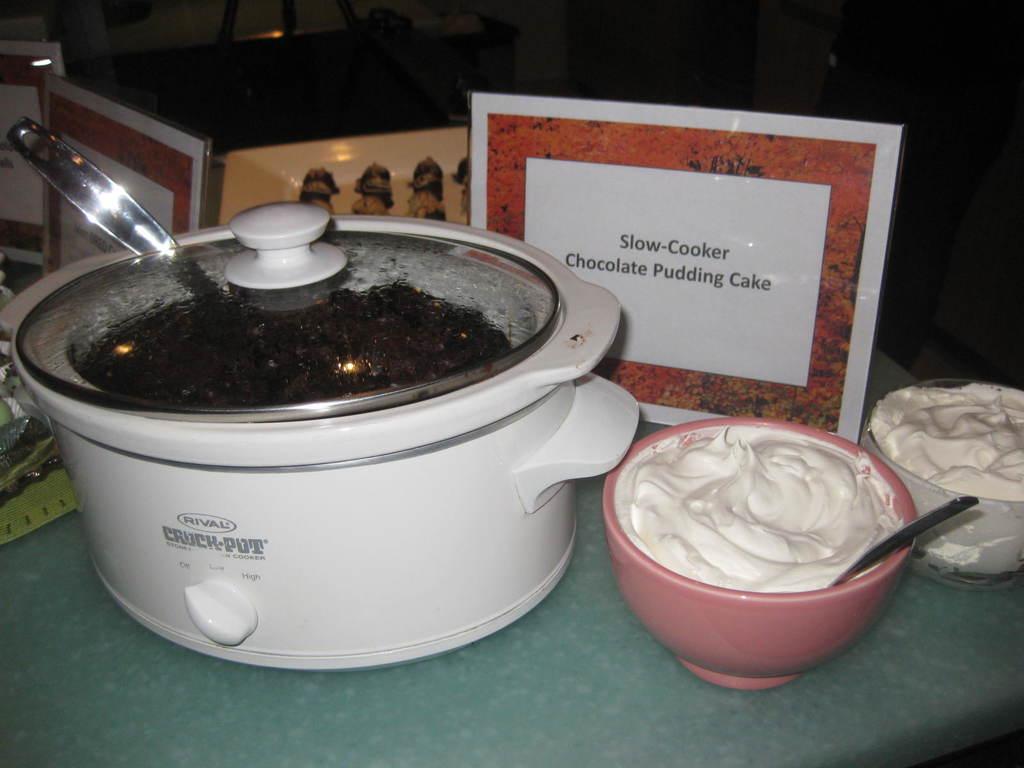What is the brand of this appliance?
Offer a terse response. Rival. What is being made in the slow cooker?
Offer a terse response. Chocolate pudding cake. 